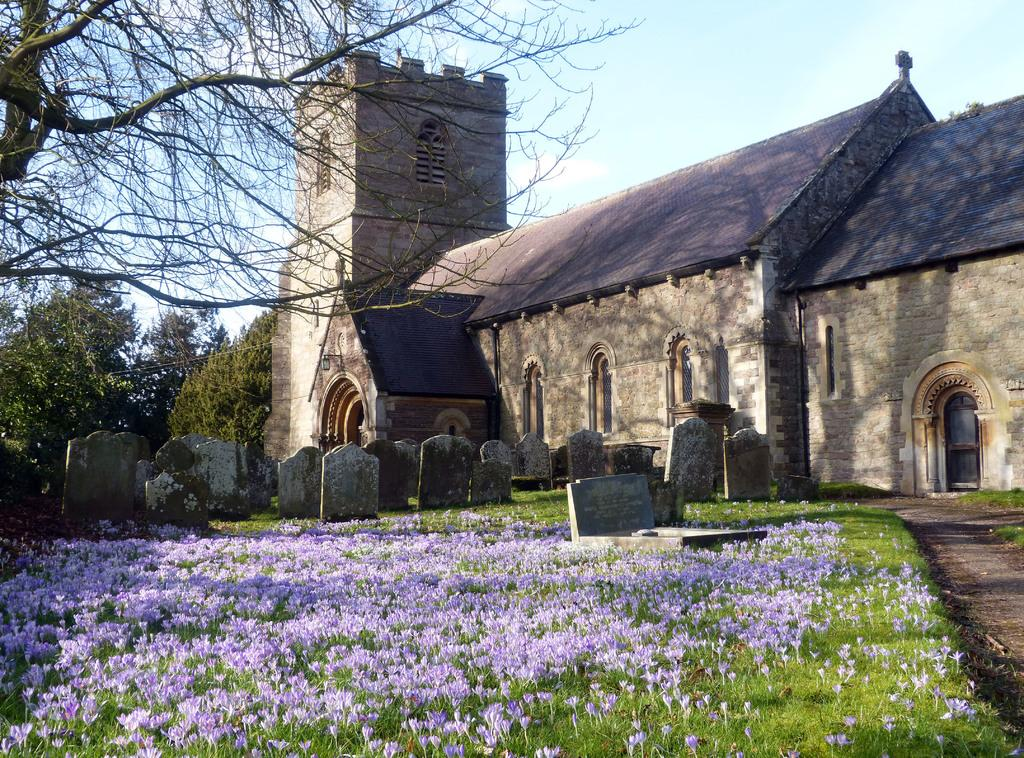What type of structures can be seen in the image? There are houses in the image. What feature do the houses have? The houses have windows. What other natural elements are present in the image? There are trees in the image. What type of flowers can be seen in the image? There are purple color flowers in the image. What additional objects can be seen in the image? There are tombstones in the image. What is the color of the sky in the image? The sky is blue and white in color. What type of police form can be seen on the ground in the image? There is no police form present in the image. What type of card is being used to play a game in the image? There is no card game present in the image. 